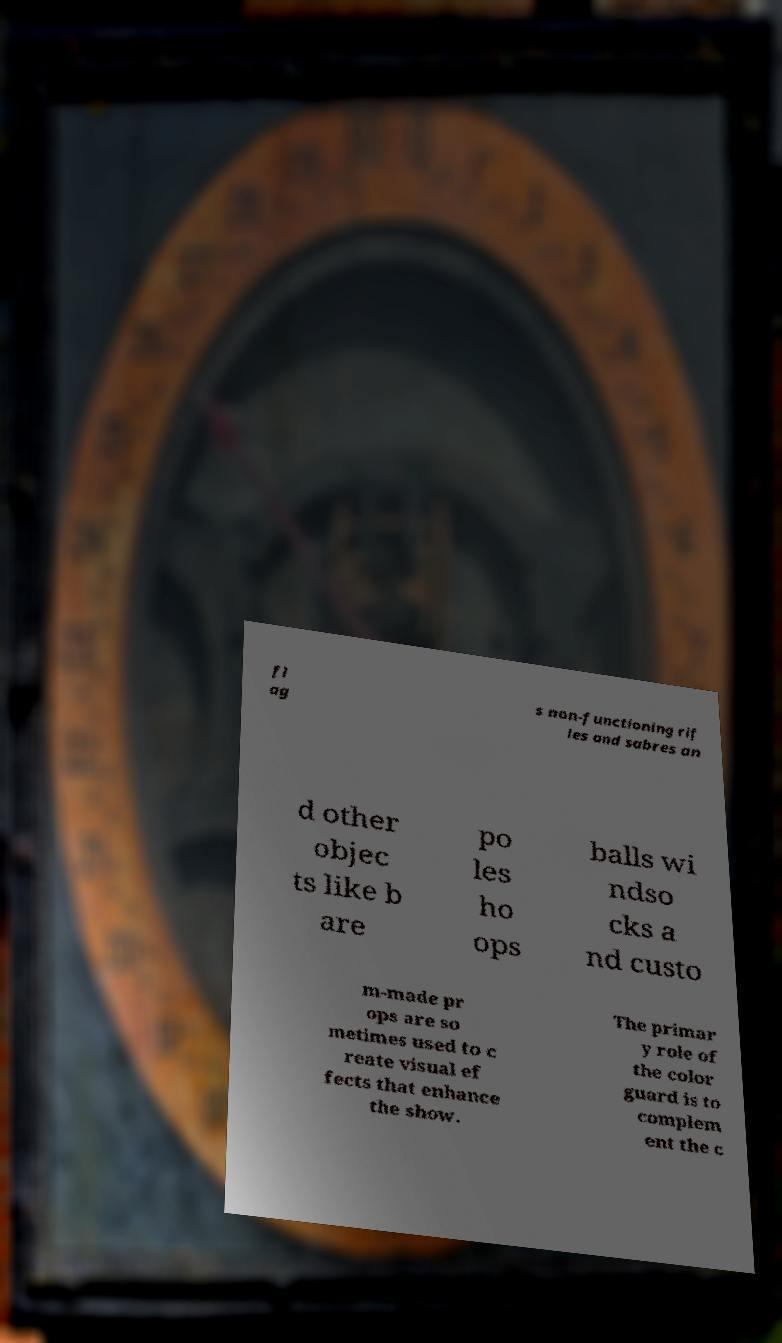There's text embedded in this image that I need extracted. Can you transcribe it verbatim? fl ag s non-functioning rif les and sabres an d other objec ts like b are po les ho ops balls wi ndso cks a nd custo m-made pr ops are so metimes used to c reate visual ef fects that enhance the show. The primar y role of the color guard is to complem ent the c 